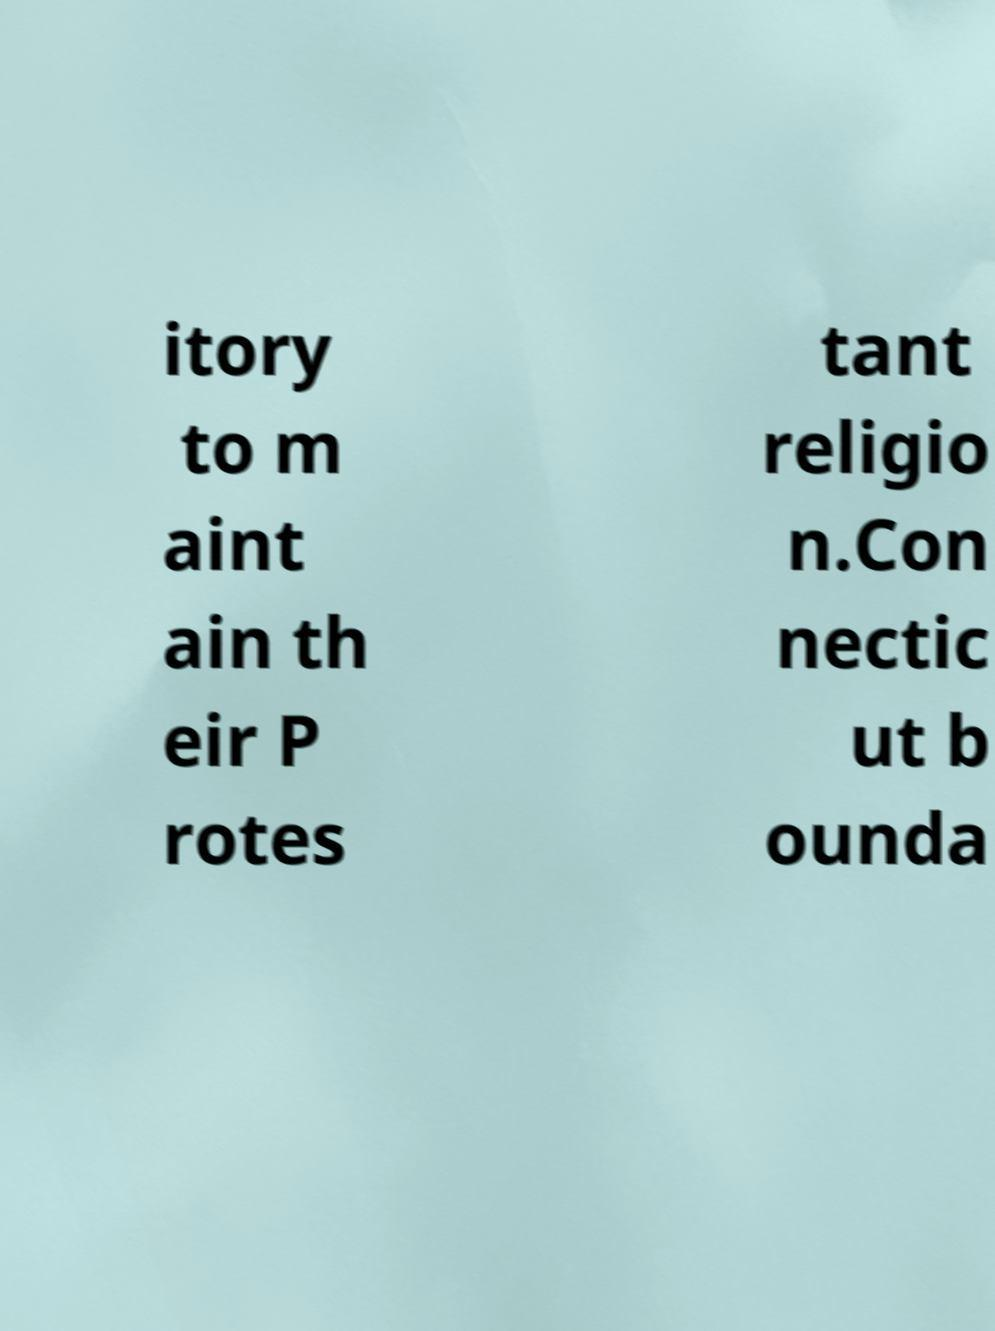Please read and relay the text visible in this image. What does it say? itory to m aint ain th eir P rotes tant religio n.Con nectic ut b ounda 